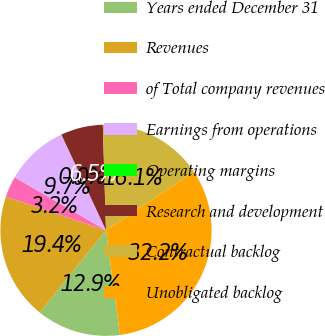<chart> <loc_0><loc_0><loc_500><loc_500><pie_chart><fcel>Years ended December 31<fcel>Revenues<fcel>of Total company revenues<fcel>Earnings from operations<fcel>Operating margins<fcel>Research and development<fcel>Contractual backlog<fcel>Unobligated backlog<nl><fcel>12.9%<fcel>19.35%<fcel>3.23%<fcel>9.68%<fcel>0.01%<fcel>6.46%<fcel>16.13%<fcel>32.24%<nl></chart> 